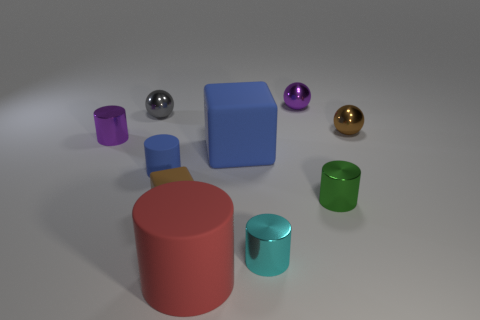Subtract all small green metallic cylinders. How many cylinders are left? 4 Subtract all green cylinders. How many cylinders are left? 4 Subtract all blocks. How many objects are left? 8 Subtract 1 cylinders. How many cylinders are left? 4 Add 4 large red cylinders. How many large red cylinders exist? 5 Subtract 0 gray blocks. How many objects are left? 10 Subtract all cyan blocks. Subtract all purple cylinders. How many blocks are left? 2 Subtract all small brown spheres. Subtract all big blue things. How many objects are left? 8 Add 8 tiny blue matte objects. How many tiny blue matte objects are left? 9 